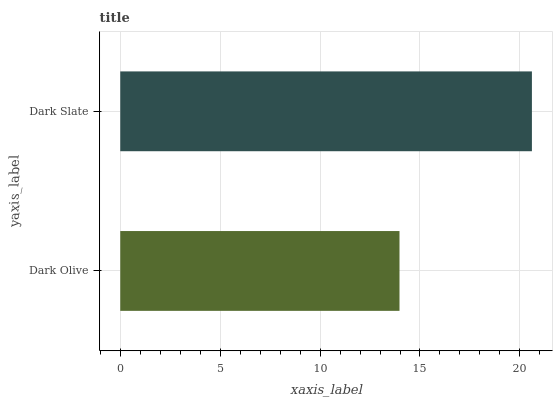Is Dark Olive the minimum?
Answer yes or no. Yes. Is Dark Slate the maximum?
Answer yes or no. Yes. Is Dark Slate the minimum?
Answer yes or no. No. Is Dark Slate greater than Dark Olive?
Answer yes or no. Yes. Is Dark Olive less than Dark Slate?
Answer yes or no. Yes. Is Dark Olive greater than Dark Slate?
Answer yes or no. No. Is Dark Slate less than Dark Olive?
Answer yes or no. No. Is Dark Slate the high median?
Answer yes or no. Yes. Is Dark Olive the low median?
Answer yes or no. Yes. Is Dark Olive the high median?
Answer yes or no. No. Is Dark Slate the low median?
Answer yes or no. No. 